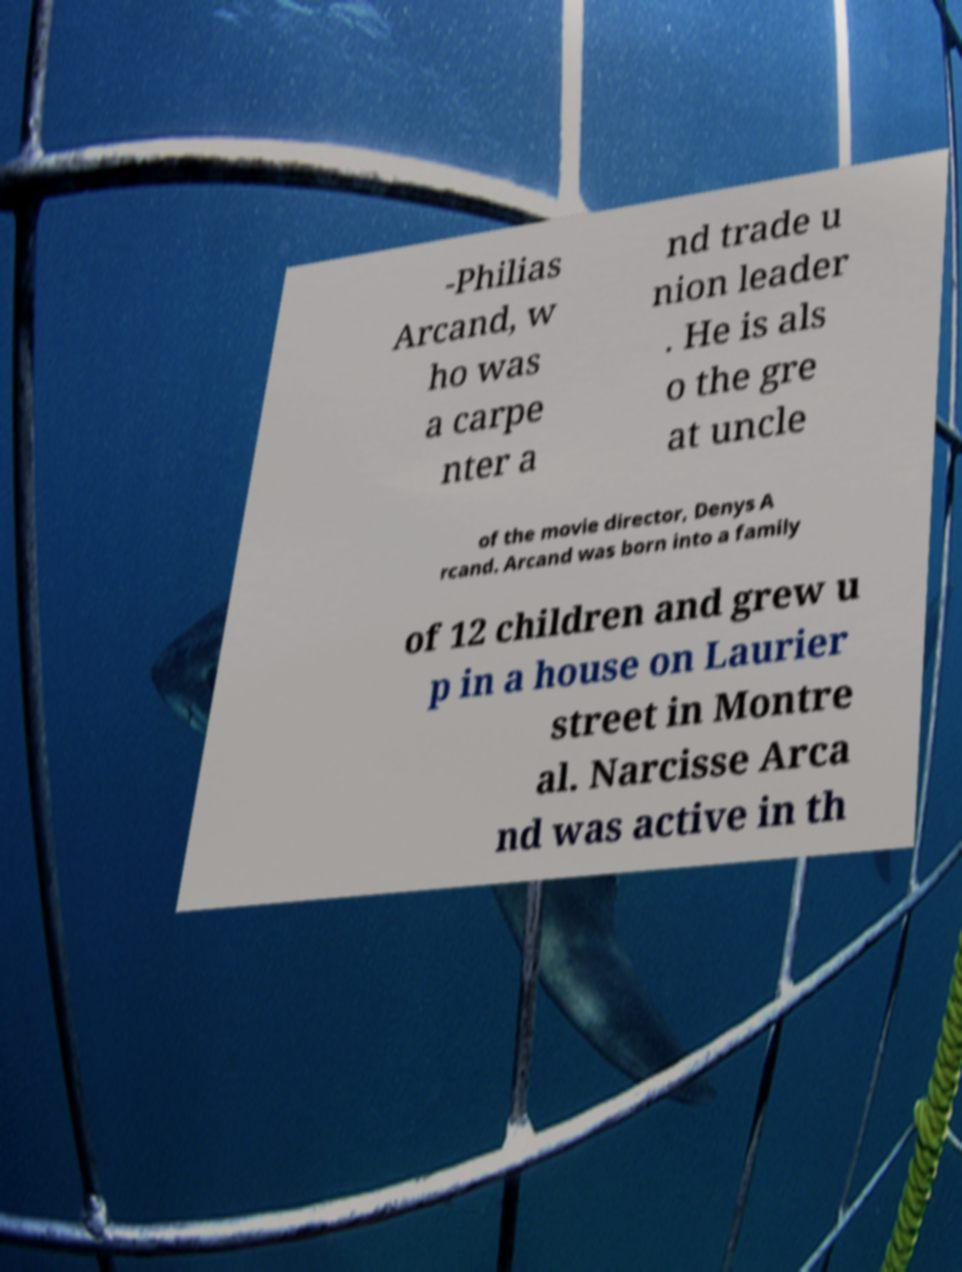Could you extract and type out the text from this image? -Philias Arcand, w ho was a carpe nter a nd trade u nion leader . He is als o the gre at uncle of the movie director, Denys A rcand. Arcand was born into a family of 12 children and grew u p in a house on Laurier street in Montre al. Narcisse Arca nd was active in th 